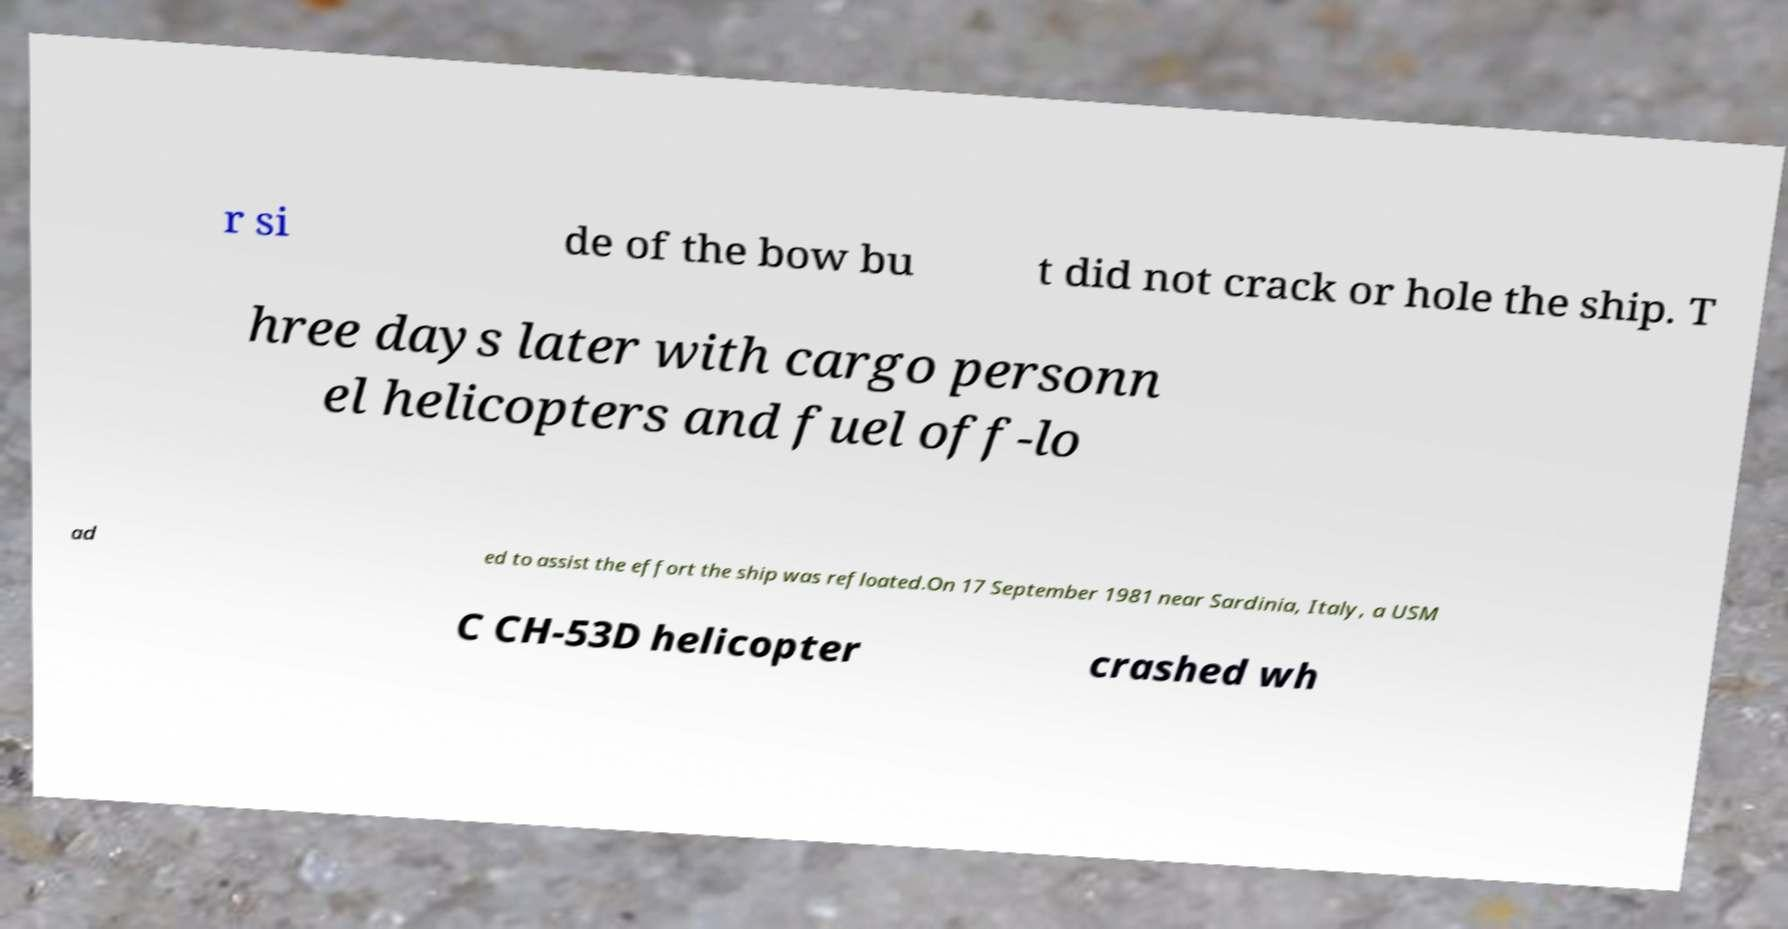For documentation purposes, I need the text within this image transcribed. Could you provide that? r si de of the bow bu t did not crack or hole the ship. T hree days later with cargo personn el helicopters and fuel off-lo ad ed to assist the effort the ship was refloated.On 17 September 1981 near Sardinia, Italy, a USM C CH-53D helicopter crashed wh 